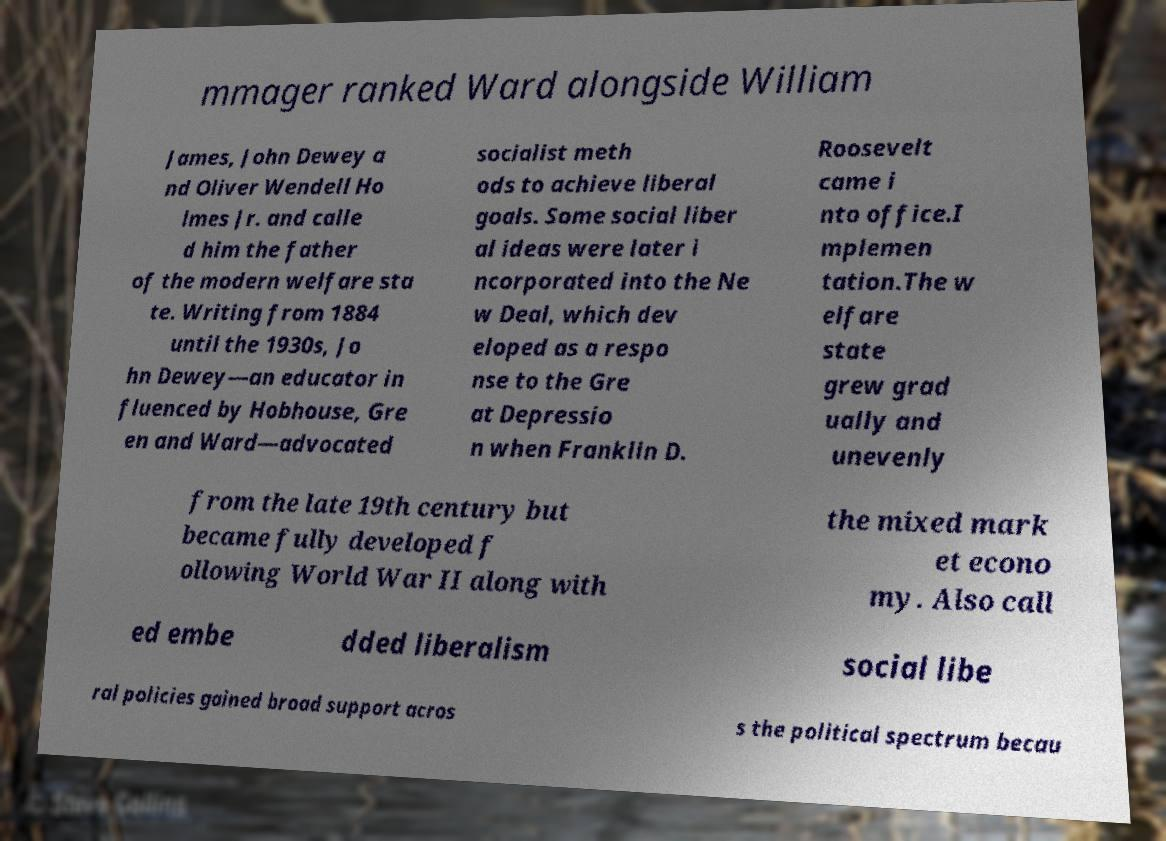Could you assist in decoding the text presented in this image and type it out clearly? mmager ranked Ward alongside William James, John Dewey a nd Oliver Wendell Ho lmes Jr. and calle d him the father of the modern welfare sta te. Writing from 1884 until the 1930s, Jo hn Dewey—an educator in fluenced by Hobhouse, Gre en and Ward—advocated socialist meth ods to achieve liberal goals. Some social liber al ideas were later i ncorporated into the Ne w Deal, which dev eloped as a respo nse to the Gre at Depressio n when Franklin D. Roosevelt came i nto office.I mplemen tation.The w elfare state grew grad ually and unevenly from the late 19th century but became fully developed f ollowing World War II along with the mixed mark et econo my. Also call ed embe dded liberalism social libe ral policies gained broad support acros s the political spectrum becau 